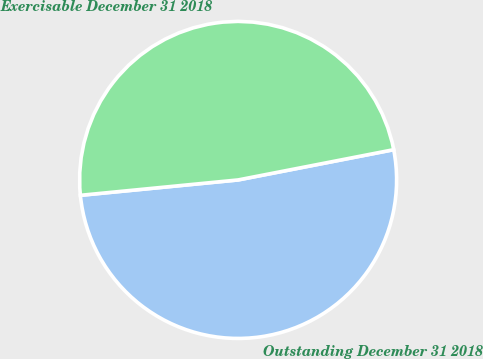<chart> <loc_0><loc_0><loc_500><loc_500><pie_chart><fcel>Outstanding December 31 2018<fcel>Exercisable December 31 2018<nl><fcel>51.51%<fcel>48.49%<nl></chart> 